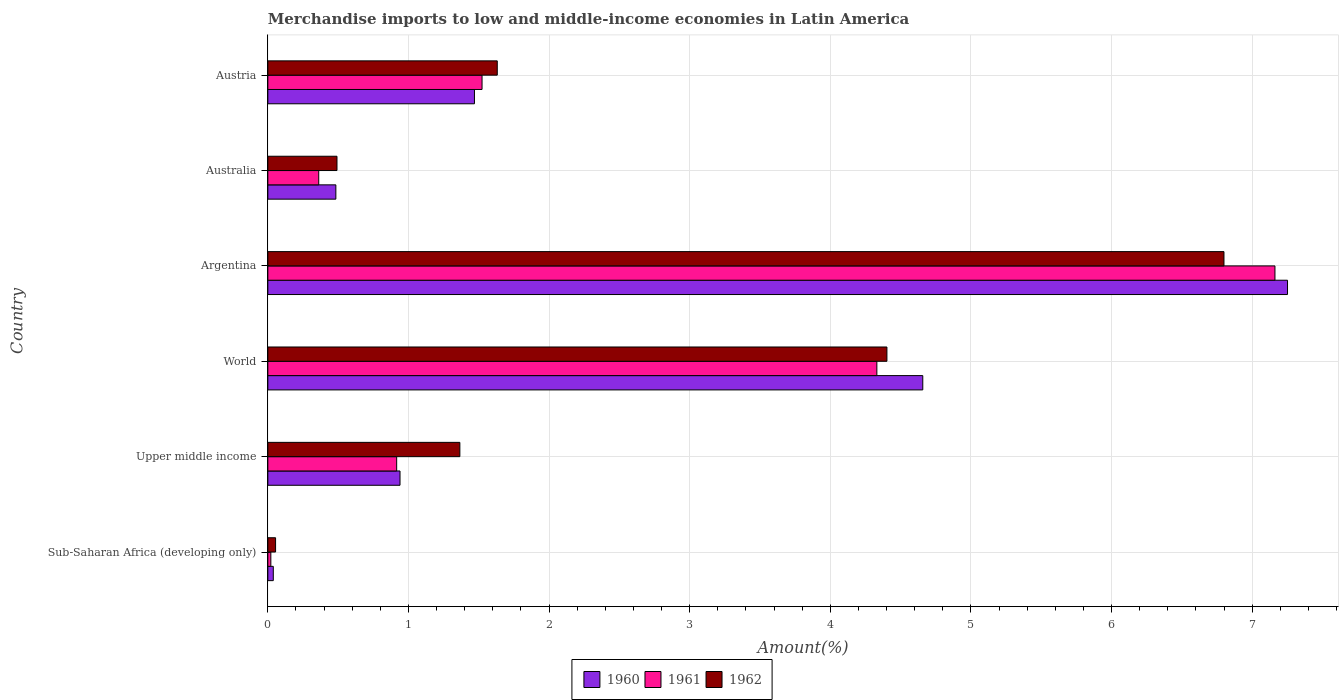How many groups of bars are there?
Your response must be concise. 6. How many bars are there on the 4th tick from the top?
Offer a very short reply. 3. How many bars are there on the 6th tick from the bottom?
Give a very brief answer. 3. What is the label of the 4th group of bars from the top?
Make the answer very short. World. What is the percentage of amount earned from merchandise imports in 1961 in Argentina?
Your answer should be compact. 7.16. Across all countries, what is the maximum percentage of amount earned from merchandise imports in 1960?
Your answer should be compact. 7.25. Across all countries, what is the minimum percentage of amount earned from merchandise imports in 1960?
Your answer should be compact. 0.04. In which country was the percentage of amount earned from merchandise imports in 1961 minimum?
Your response must be concise. Sub-Saharan Africa (developing only). What is the total percentage of amount earned from merchandise imports in 1960 in the graph?
Ensure brevity in your answer.  14.84. What is the difference between the percentage of amount earned from merchandise imports in 1961 in Upper middle income and that in World?
Make the answer very short. -3.42. What is the difference between the percentage of amount earned from merchandise imports in 1960 in Argentina and the percentage of amount earned from merchandise imports in 1962 in World?
Make the answer very short. 2.85. What is the average percentage of amount earned from merchandise imports in 1962 per country?
Offer a very short reply. 2.46. What is the difference between the percentage of amount earned from merchandise imports in 1962 and percentage of amount earned from merchandise imports in 1961 in Upper middle income?
Your answer should be very brief. 0.45. What is the ratio of the percentage of amount earned from merchandise imports in 1961 in Austria to that in World?
Your response must be concise. 0.35. Is the difference between the percentage of amount earned from merchandise imports in 1962 in Australia and Sub-Saharan Africa (developing only) greater than the difference between the percentage of amount earned from merchandise imports in 1961 in Australia and Sub-Saharan Africa (developing only)?
Your answer should be compact. Yes. What is the difference between the highest and the second highest percentage of amount earned from merchandise imports in 1960?
Your answer should be compact. 2.59. What is the difference between the highest and the lowest percentage of amount earned from merchandise imports in 1960?
Keep it short and to the point. 7.21. In how many countries, is the percentage of amount earned from merchandise imports in 1961 greater than the average percentage of amount earned from merchandise imports in 1961 taken over all countries?
Your response must be concise. 2. Is the sum of the percentage of amount earned from merchandise imports in 1961 in Australia and Upper middle income greater than the maximum percentage of amount earned from merchandise imports in 1962 across all countries?
Offer a terse response. No. How many bars are there?
Your response must be concise. 18. Are the values on the major ticks of X-axis written in scientific E-notation?
Keep it short and to the point. No. Where does the legend appear in the graph?
Your response must be concise. Bottom center. How many legend labels are there?
Ensure brevity in your answer.  3. How are the legend labels stacked?
Ensure brevity in your answer.  Horizontal. What is the title of the graph?
Offer a terse response. Merchandise imports to low and middle-income economies in Latin America. Does "1986" appear as one of the legend labels in the graph?
Offer a very short reply. No. What is the label or title of the X-axis?
Provide a succinct answer. Amount(%). What is the Amount(%) of 1960 in Sub-Saharan Africa (developing only)?
Give a very brief answer. 0.04. What is the Amount(%) in 1961 in Sub-Saharan Africa (developing only)?
Offer a very short reply. 0.02. What is the Amount(%) in 1962 in Sub-Saharan Africa (developing only)?
Provide a succinct answer. 0.06. What is the Amount(%) of 1960 in Upper middle income?
Offer a terse response. 0.94. What is the Amount(%) of 1961 in Upper middle income?
Your answer should be compact. 0.92. What is the Amount(%) in 1962 in Upper middle income?
Provide a succinct answer. 1.37. What is the Amount(%) of 1960 in World?
Your answer should be very brief. 4.66. What is the Amount(%) in 1961 in World?
Offer a terse response. 4.33. What is the Amount(%) of 1962 in World?
Your answer should be compact. 4.4. What is the Amount(%) of 1960 in Argentina?
Ensure brevity in your answer.  7.25. What is the Amount(%) in 1961 in Argentina?
Give a very brief answer. 7.16. What is the Amount(%) of 1962 in Argentina?
Offer a very short reply. 6.8. What is the Amount(%) in 1960 in Australia?
Provide a succinct answer. 0.48. What is the Amount(%) of 1961 in Australia?
Offer a very short reply. 0.36. What is the Amount(%) of 1962 in Australia?
Make the answer very short. 0.49. What is the Amount(%) of 1960 in Austria?
Your response must be concise. 1.47. What is the Amount(%) of 1961 in Austria?
Make the answer very short. 1.52. What is the Amount(%) in 1962 in Austria?
Offer a very short reply. 1.63. Across all countries, what is the maximum Amount(%) of 1960?
Provide a short and direct response. 7.25. Across all countries, what is the maximum Amount(%) of 1961?
Offer a very short reply. 7.16. Across all countries, what is the maximum Amount(%) in 1962?
Offer a very short reply. 6.8. Across all countries, what is the minimum Amount(%) in 1960?
Keep it short and to the point. 0.04. Across all countries, what is the minimum Amount(%) in 1961?
Your response must be concise. 0.02. Across all countries, what is the minimum Amount(%) of 1962?
Provide a short and direct response. 0.06. What is the total Amount(%) in 1960 in the graph?
Ensure brevity in your answer.  14.84. What is the total Amount(%) of 1961 in the graph?
Your response must be concise. 14.32. What is the total Amount(%) in 1962 in the graph?
Give a very brief answer. 14.75. What is the difference between the Amount(%) of 1960 in Sub-Saharan Africa (developing only) and that in Upper middle income?
Keep it short and to the point. -0.9. What is the difference between the Amount(%) of 1961 in Sub-Saharan Africa (developing only) and that in Upper middle income?
Your answer should be very brief. -0.89. What is the difference between the Amount(%) of 1962 in Sub-Saharan Africa (developing only) and that in Upper middle income?
Ensure brevity in your answer.  -1.31. What is the difference between the Amount(%) of 1960 in Sub-Saharan Africa (developing only) and that in World?
Your answer should be compact. -4.62. What is the difference between the Amount(%) of 1961 in Sub-Saharan Africa (developing only) and that in World?
Your answer should be very brief. -4.31. What is the difference between the Amount(%) of 1962 in Sub-Saharan Africa (developing only) and that in World?
Ensure brevity in your answer.  -4.35. What is the difference between the Amount(%) in 1960 in Sub-Saharan Africa (developing only) and that in Argentina?
Provide a short and direct response. -7.21. What is the difference between the Amount(%) in 1961 in Sub-Saharan Africa (developing only) and that in Argentina?
Give a very brief answer. -7.14. What is the difference between the Amount(%) in 1962 in Sub-Saharan Africa (developing only) and that in Argentina?
Make the answer very short. -6.74. What is the difference between the Amount(%) of 1960 in Sub-Saharan Africa (developing only) and that in Australia?
Offer a terse response. -0.45. What is the difference between the Amount(%) in 1961 in Sub-Saharan Africa (developing only) and that in Australia?
Ensure brevity in your answer.  -0.34. What is the difference between the Amount(%) of 1962 in Sub-Saharan Africa (developing only) and that in Australia?
Your answer should be very brief. -0.44. What is the difference between the Amount(%) in 1960 in Sub-Saharan Africa (developing only) and that in Austria?
Your response must be concise. -1.43. What is the difference between the Amount(%) of 1961 in Sub-Saharan Africa (developing only) and that in Austria?
Make the answer very short. -1.5. What is the difference between the Amount(%) of 1962 in Sub-Saharan Africa (developing only) and that in Austria?
Give a very brief answer. -1.58. What is the difference between the Amount(%) in 1960 in Upper middle income and that in World?
Give a very brief answer. -3.72. What is the difference between the Amount(%) in 1961 in Upper middle income and that in World?
Offer a very short reply. -3.42. What is the difference between the Amount(%) in 1962 in Upper middle income and that in World?
Your response must be concise. -3.04. What is the difference between the Amount(%) of 1960 in Upper middle income and that in Argentina?
Ensure brevity in your answer.  -6.31. What is the difference between the Amount(%) of 1961 in Upper middle income and that in Argentina?
Make the answer very short. -6.25. What is the difference between the Amount(%) in 1962 in Upper middle income and that in Argentina?
Keep it short and to the point. -5.43. What is the difference between the Amount(%) in 1960 in Upper middle income and that in Australia?
Offer a very short reply. 0.46. What is the difference between the Amount(%) in 1961 in Upper middle income and that in Australia?
Your answer should be compact. 0.55. What is the difference between the Amount(%) of 1962 in Upper middle income and that in Australia?
Provide a short and direct response. 0.87. What is the difference between the Amount(%) of 1960 in Upper middle income and that in Austria?
Your answer should be very brief. -0.53. What is the difference between the Amount(%) of 1961 in Upper middle income and that in Austria?
Ensure brevity in your answer.  -0.61. What is the difference between the Amount(%) in 1962 in Upper middle income and that in Austria?
Give a very brief answer. -0.27. What is the difference between the Amount(%) in 1960 in World and that in Argentina?
Provide a short and direct response. -2.59. What is the difference between the Amount(%) in 1961 in World and that in Argentina?
Keep it short and to the point. -2.83. What is the difference between the Amount(%) of 1962 in World and that in Argentina?
Provide a succinct answer. -2.4. What is the difference between the Amount(%) of 1960 in World and that in Australia?
Your answer should be compact. 4.17. What is the difference between the Amount(%) of 1961 in World and that in Australia?
Offer a terse response. 3.97. What is the difference between the Amount(%) of 1962 in World and that in Australia?
Ensure brevity in your answer.  3.91. What is the difference between the Amount(%) of 1960 in World and that in Austria?
Provide a succinct answer. 3.19. What is the difference between the Amount(%) of 1961 in World and that in Austria?
Keep it short and to the point. 2.81. What is the difference between the Amount(%) in 1962 in World and that in Austria?
Ensure brevity in your answer.  2.77. What is the difference between the Amount(%) of 1960 in Argentina and that in Australia?
Offer a very short reply. 6.77. What is the difference between the Amount(%) in 1961 in Argentina and that in Australia?
Offer a terse response. 6.8. What is the difference between the Amount(%) in 1962 in Argentina and that in Australia?
Your answer should be compact. 6.31. What is the difference between the Amount(%) in 1960 in Argentina and that in Austria?
Make the answer very short. 5.78. What is the difference between the Amount(%) of 1961 in Argentina and that in Austria?
Your answer should be compact. 5.64. What is the difference between the Amount(%) of 1962 in Argentina and that in Austria?
Provide a succinct answer. 5.17. What is the difference between the Amount(%) in 1960 in Australia and that in Austria?
Your answer should be very brief. -0.99. What is the difference between the Amount(%) in 1961 in Australia and that in Austria?
Provide a succinct answer. -1.16. What is the difference between the Amount(%) in 1962 in Australia and that in Austria?
Your response must be concise. -1.14. What is the difference between the Amount(%) in 1960 in Sub-Saharan Africa (developing only) and the Amount(%) in 1961 in Upper middle income?
Offer a very short reply. -0.88. What is the difference between the Amount(%) in 1960 in Sub-Saharan Africa (developing only) and the Amount(%) in 1962 in Upper middle income?
Your response must be concise. -1.33. What is the difference between the Amount(%) of 1961 in Sub-Saharan Africa (developing only) and the Amount(%) of 1962 in Upper middle income?
Provide a short and direct response. -1.34. What is the difference between the Amount(%) of 1960 in Sub-Saharan Africa (developing only) and the Amount(%) of 1961 in World?
Your answer should be very brief. -4.29. What is the difference between the Amount(%) in 1960 in Sub-Saharan Africa (developing only) and the Amount(%) in 1962 in World?
Your answer should be compact. -4.36. What is the difference between the Amount(%) of 1961 in Sub-Saharan Africa (developing only) and the Amount(%) of 1962 in World?
Keep it short and to the point. -4.38. What is the difference between the Amount(%) in 1960 in Sub-Saharan Africa (developing only) and the Amount(%) in 1961 in Argentina?
Provide a short and direct response. -7.12. What is the difference between the Amount(%) of 1960 in Sub-Saharan Africa (developing only) and the Amount(%) of 1962 in Argentina?
Give a very brief answer. -6.76. What is the difference between the Amount(%) of 1961 in Sub-Saharan Africa (developing only) and the Amount(%) of 1962 in Argentina?
Keep it short and to the point. -6.78. What is the difference between the Amount(%) of 1960 in Sub-Saharan Africa (developing only) and the Amount(%) of 1961 in Australia?
Your answer should be very brief. -0.32. What is the difference between the Amount(%) in 1960 in Sub-Saharan Africa (developing only) and the Amount(%) in 1962 in Australia?
Give a very brief answer. -0.45. What is the difference between the Amount(%) in 1961 in Sub-Saharan Africa (developing only) and the Amount(%) in 1962 in Australia?
Your answer should be very brief. -0.47. What is the difference between the Amount(%) in 1960 in Sub-Saharan Africa (developing only) and the Amount(%) in 1961 in Austria?
Ensure brevity in your answer.  -1.48. What is the difference between the Amount(%) of 1960 in Sub-Saharan Africa (developing only) and the Amount(%) of 1962 in Austria?
Your response must be concise. -1.59. What is the difference between the Amount(%) in 1961 in Sub-Saharan Africa (developing only) and the Amount(%) in 1962 in Austria?
Offer a very short reply. -1.61. What is the difference between the Amount(%) of 1960 in Upper middle income and the Amount(%) of 1961 in World?
Provide a short and direct response. -3.39. What is the difference between the Amount(%) in 1960 in Upper middle income and the Amount(%) in 1962 in World?
Provide a succinct answer. -3.46. What is the difference between the Amount(%) in 1961 in Upper middle income and the Amount(%) in 1962 in World?
Give a very brief answer. -3.49. What is the difference between the Amount(%) of 1960 in Upper middle income and the Amount(%) of 1961 in Argentina?
Your answer should be very brief. -6.22. What is the difference between the Amount(%) in 1960 in Upper middle income and the Amount(%) in 1962 in Argentina?
Give a very brief answer. -5.86. What is the difference between the Amount(%) of 1961 in Upper middle income and the Amount(%) of 1962 in Argentina?
Offer a very short reply. -5.88. What is the difference between the Amount(%) of 1960 in Upper middle income and the Amount(%) of 1961 in Australia?
Provide a succinct answer. 0.58. What is the difference between the Amount(%) of 1960 in Upper middle income and the Amount(%) of 1962 in Australia?
Your response must be concise. 0.45. What is the difference between the Amount(%) in 1961 in Upper middle income and the Amount(%) in 1962 in Australia?
Ensure brevity in your answer.  0.42. What is the difference between the Amount(%) of 1960 in Upper middle income and the Amount(%) of 1961 in Austria?
Your answer should be compact. -0.58. What is the difference between the Amount(%) in 1960 in Upper middle income and the Amount(%) in 1962 in Austria?
Your answer should be very brief. -0.69. What is the difference between the Amount(%) in 1961 in Upper middle income and the Amount(%) in 1962 in Austria?
Provide a short and direct response. -0.72. What is the difference between the Amount(%) in 1960 in World and the Amount(%) in 1961 in Argentina?
Offer a terse response. -2.5. What is the difference between the Amount(%) in 1960 in World and the Amount(%) in 1962 in Argentina?
Offer a terse response. -2.14. What is the difference between the Amount(%) in 1961 in World and the Amount(%) in 1962 in Argentina?
Ensure brevity in your answer.  -2.47. What is the difference between the Amount(%) of 1960 in World and the Amount(%) of 1961 in Australia?
Your answer should be very brief. 4.3. What is the difference between the Amount(%) of 1960 in World and the Amount(%) of 1962 in Australia?
Offer a very short reply. 4.17. What is the difference between the Amount(%) of 1961 in World and the Amount(%) of 1962 in Australia?
Your answer should be compact. 3.84. What is the difference between the Amount(%) in 1960 in World and the Amount(%) in 1961 in Austria?
Keep it short and to the point. 3.13. What is the difference between the Amount(%) of 1960 in World and the Amount(%) of 1962 in Austria?
Offer a terse response. 3.03. What is the difference between the Amount(%) of 1961 in World and the Amount(%) of 1962 in Austria?
Your answer should be compact. 2.7. What is the difference between the Amount(%) of 1960 in Argentina and the Amount(%) of 1961 in Australia?
Offer a terse response. 6.89. What is the difference between the Amount(%) in 1960 in Argentina and the Amount(%) in 1962 in Australia?
Your answer should be very brief. 6.76. What is the difference between the Amount(%) in 1961 in Argentina and the Amount(%) in 1962 in Australia?
Provide a succinct answer. 6.67. What is the difference between the Amount(%) in 1960 in Argentina and the Amount(%) in 1961 in Austria?
Ensure brevity in your answer.  5.73. What is the difference between the Amount(%) of 1960 in Argentina and the Amount(%) of 1962 in Austria?
Offer a terse response. 5.62. What is the difference between the Amount(%) in 1961 in Argentina and the Amount(%) in 1962 in Austria?
Your answer should be compact. 5.53. What is the difference between the Amount(%) of 1960 in Australia and the Amount(%) of 1961 in Austria?
Your response must be concise. -1.04. What is the difference between the Amount(%) in 1960 in Australia and the Amount(%) in 1962 in Austria?
Make the answer very short. -1.15. What is the difference between the Amount(%) in 1961 in Australia and the Amount(%) in 1962 in Austria?
Offer a very short reply. -1.27. What is the average Amount(%) in 1960 per country?
Offer a terse response. 2.47. What is the average Amount(%) in 1961 per country?
Your answer should be very brief. 2.39. What is the average Amount(%) in 1962 per country?
Your answer should be very brief. 2.46. What is the difference between the Amount(%) of 1960 and Amount(%) of 1961 in Sub-Saharan Africa (developing only)?
Your answer should be compact. 0.02. What is the difference between the Amount(%) of 1960 and Amount(%) of 1962 in Sub-Saharan Africa (developing only)?
Ensure brevity in your answer.  -0.02. What is the difference between the Amount(%) of 1961 and Amount(%) of 1962 in Sub-Saharan Africa (developing only)?
Offer a very short reply. -0.03. What is the difference between the Amount(%) in 1960 and Amount(%) in 1961 in Upper middle income?
Make the answer very short. 0.02. What is the difference between the Amount(%) of 1960 and Amount(%) of 1962 in Upper middle income?
Your answer should be compact. -0.43. What is the difference between the Amount(%) in 1961 and Amount(%) in 1962 in Upper middle income?
Your response must be concise. -0.45. What is the difference between the Amount(%) in 1960 and Amount(%) in 1961 in World?
Make the answer very short. 0.33. What is the difference between the Amount(%) in 1960 and Amount(%) in 1962 in World?
Your answer should be very brief. 0.26. What is the difference between the Amount(%) in 1961 and Amount(%) in 1962 in World?
Your answer should be compact. -0.07. What is the difference between the Amount(%) of 1960 and Amount(%) of 1961 in Argentina?
Make the answer very short. 0.09. What is the difference between the Amount(%) in 1960 and Amount(%) in 1962 in Argentina?
Give a very brief answer. 0.45. What is the difference between the Amount(%) in 1961 and Amount(%) in 1962 in Argentina?
Make the answer very short. 0.36. What is the difference between the Amount(%) of 1960 and Amount(%) of 1961 in Australia?
Your response must be concise. 0.12. What is the difference between the Amount(%) of 1960 and Amount(%) of 1962 in Australia?
Your answer should be very brief. -0.01. What is the difference between the Amount(%) in 1961 and Amount(%) in 1962 in Australia?
Provide a succinct answer. -0.13. What is the difference between the Amount(%) in 1960 and Amount(%) in 1961 in Austria?
Provide a succinct answer. -0.05. What is the difference between the Amount(%) in 1960 and Amount(%) in 1962 in Austria?
Make the answer very short. -0.16. What is the difference between the Amount(%) of 1961 and Amount(%) of 1962 in Austria?
Offer a very short reply. -0.11. What is the ratio of the Amount(%) in 1960 in Sub-Saharan Africa (developing only) to that in Upper middle income?
Your answer should be very brief. 0.04. What is the ratio of the Amount(%) in 1961 in Sub-Saharan Africa (developing only) to that in Upper middle income?
Ensure brevity in your answer.  0.02. What is the ratio of the Amount(%) in 1962 in Sub-Saharan Africa (developing only) to that in Upper middle income?
Your response must be concise. 0.04. What is the ratio of the Amount(%) in 1960 in Sub-Saharan Africa (developing only) to that in World?
Make the answer very short. 0.01. What is the ratio of the Amount(%) in 1961 in Sub-Saharan Africa (developing only) to that in World?
Give a very brief answer. 0. What is the ratio of the Amount(%) in 1962 in Sub-Saharan Africa (developing only) to that in World?
Your answer should be very brief. 0.01. What is the ratio of the Amount(%) of 1960 in Sub-Saharan Africa (developing only) to that in Argentina?
Offer a terse response. 0.01. What is the ratio of the Amount(%) in 1961 in Sub-Saharan Africa (developing only) to that in Argentina?
Provide a short and direct response. 0. What is the ratio of the Amount(%) in 1962 in Sub-Saharan Africa (developing only) to that in Argentina?
Provide a short and direct response. 0.01. What is the ratio of the Amount(%) of 1961 in Sub-Saharan Africa (developing only) to that in Australia?
Keep it short and to the point. 0.06. What is the ratio of the Amount(%) of 1962 in Sub-Saharan Africa (developing only) to that in Australia?
Make the answer very short. 0.11. What is the ratio of the Amount(%) of 1960 in Sub-Saharan Africa (developing only) to that in Austria?
Offer a very short reply. 0.03. What is the ratio of the Amount(%) of 1961 in Sub-Saharan Africa (developing only) to that in Austria?
Your answer should be very brief. 0.01. What is the ratio of the Amount(%) of 1962 in Sub-Saharan Africa (developing only) to that in Austria?
Your response must be concise. 0.03. What is the ratio of the Amount(%) of 1960 in Upper middle income to that in World?
Provide a short and direct response. 0.2. What is the ratio of the Amount(%) of 1961 in Upper middle income to that in World?
Your answer should be compact. 0.21. What is the ratio of the Amount(%) of 1962 in Upper middle income to that in World?
Your response must be concise. 0.31. What is the ratio of the Amount(%) in 1960 in Upper middle income to that in Argentina?
Offer a very short reply. 0.13. What is the ratio of the Amount(%) in 1961 in Upper middle income to that in Argentina?
Offer a very short reply. 0.13. What is the ratio of the Amount(%) in 1962 in Upper middle income to that in Argentina?
Your answer should be very brief. 0.2. What is the ratio of the Amount(%) of 1960 in Upper middle income to that in Australia?
Your response must be concise. 1.94. What is the ratio of the Amount(%) in 1961 in Upper middle income to that in Australia?
Your response must be concise. 2.53. What is the ratio of the Amount(%) in 1962 in Upper middle income to that in Australia?
Provide a short and direct response. 2.78. What is the ratio of the Amount(%) of 1960 in Upper middle income to that in Austria?
Give a very brief answer. 0.64. What is the ratio of the Amount(%) in 1961 in Upper middle income to that in Austria?
Offer a very short reply. 0.6. What is the ratio of the Amount(%) of 1962 in Upper middle income to that in Austria?
Offer a very short reply. 0.84. What is the ratio of the Amount(%) in 1960 in World to that in Argentina?
Offer a very short reply. 0.64. What is the ratio of the Amount(%) in 1961 in World to that in Argentina?
Provide a succinct answer. 0.6. What is the ratio of the Amount(%) of 1962 in World to that in Argentina?
Offer a terse response. 0.65. What is the ratio of the Amount(%) in 1960 in World to that in Australia?
Provide a short and direct response. 9.63. What is the ratio of the Amount(%) in 1961 in World to that in Australia?
Offer a terse response. 11.97. What is the ratio of the Amount(%) in 1962 in World to that in Australia?
Make the answer very short. 8.95. What is the ratio of the Amount(%) of 1960 in World to that in Austria?
Offer a very short reply. 3.17. What is the ratio of the Amount(%) of 1961 in World to that in Austria?
Offer a very short reply. 2.84. What is the ratio of the Amount(%) in 1962 in World to that in Austria?
Offer a terse response. 2.7. What is the ratio of the Amount(%) in 1960 in Argentina to that in Australia?
Provide a short and direct response. 14.99. What is the ratio of the Amount(%) in 1961 in Argentina to that in Australia?
Ensure brevity in your answer.  19.79. What is the ratio of the Amount(%) in 1962 in Argentina to that in Australia?
Your answer should be very brief. 13.83. What is the ratio of the Amount(%) of 1960 in Argentina to that in Austria?
Your answer should be very brief. 4.94. What is the ratio of the Amount(%) of 1961 in Argentina to that in Austria?
Ensure brevity in your answer.  4.7. What is the ratio of the Amount(%) in 1962 in Argentina to that in Austria?
Provide a short and direct response. 4.17. What is the ratio of the Amount(%) in 1960 in Australia to that in Austria?
Keep it short and to the point. 0.33. What is the ratio of the Amount(%) of 1961 in Australia to that in Austria?
Ensure brevity in your answer.  0.24. What is the ratio of the Amount(%) of 1962 in Australia to that in Austria?
Offer a very short reply. 0.3. What is the difference between the highest and the second highest Amount(%) of 1960?
Your answer should be compact. 2.59. What is the difference between the highest and the second highest Amount(%) in 1961?
Provide a short and direct response. 2.83. What is the difference between the highest and the second highest Amount(%) of 1962?
Offer a very short reply. 2.4. What is the difference between the highest and the lowest Amount(%) of 1960?
Your response must be concise. 7.21. What is the difference between the highest and the lowest Amount(%) of 1961?
Give a very brief answer. 7.14. What is the difference between the highest and the lowest Amount(%) in 1962?
Offer a very short reply. 6.74. 